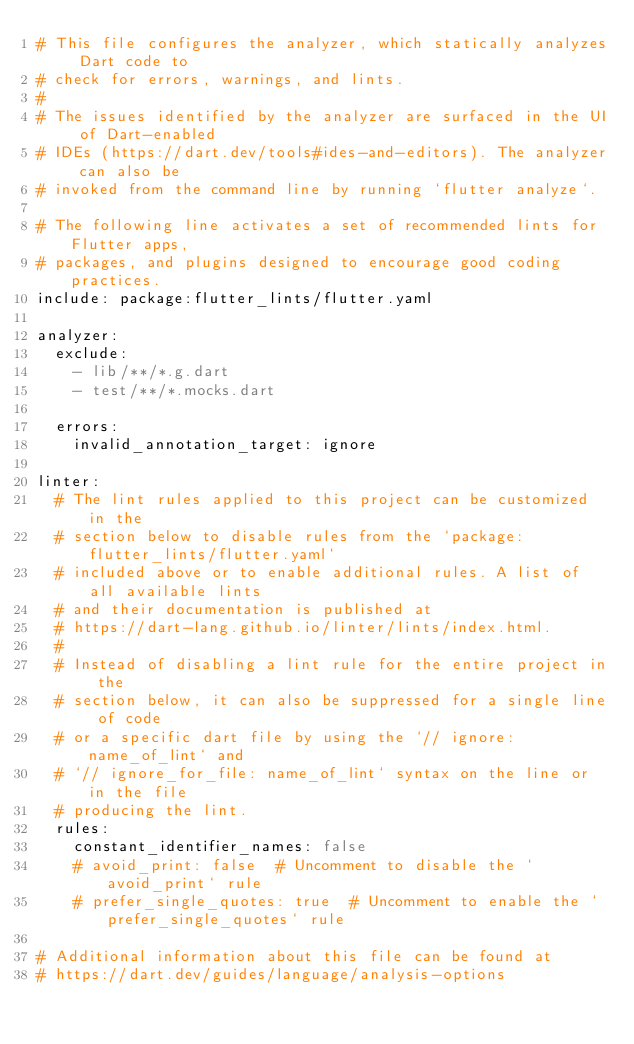Convert code to text. <code><loc_0><loc_0><loc_500><loc_500><_YAML_># This file configures the analyzer, which statically analyzes Dart code to
# check for errors, warnings, and lints.
#
# The issues identified by the analyzer are surfaced in the UI of Dart-enabled
# IDEs (https://dart.dev/tools#ides-and-editors). The analyzer can also be
# invoked from the command line by running `flutter analyze`.

# The following line activates a set of recommended lints for Flutter apps,
# packages, and plugins designed to encourage good coding practices.
include: package:flutter_lints/flutter.yaml

analyzer:
  exclude:
    - lib/**/*.g.dart
    - test/**/*.mocks.dart

  errors:
    invalid_annotation_target: ignore
    
linter:
  # The lint rules applied to this project can be customized in the
  # section below to disable rules from the `package:flutter_lints/flutter.yaml`
  # included above or to enable additional rules. A list of all available lints
  # and their documentation is published at
  # https://dart-lang.github.io/linter/lints/index.html.
  #
  # Instead of disabling a lint rule for the entire project in the
  # section below, it can also be suppressed for a single line of code
  # or a specific dart file by using the `// ignore: name_of_lint` and
  # `// ignore_for_file: name_of_lint` syntax on the line or in the file
  # producing the lint.
  rules:
    constant_identifier_names: false
    # avoid_print: false  # Uncomment to disable the `avoid_print` rule
    # prefer_single_quotes: true  # Uncomment to enable the `prefer_single_quotes` rule

# Additional information about this file can be found at
# https://dart.dev/guides/language/analysis-options</code> 